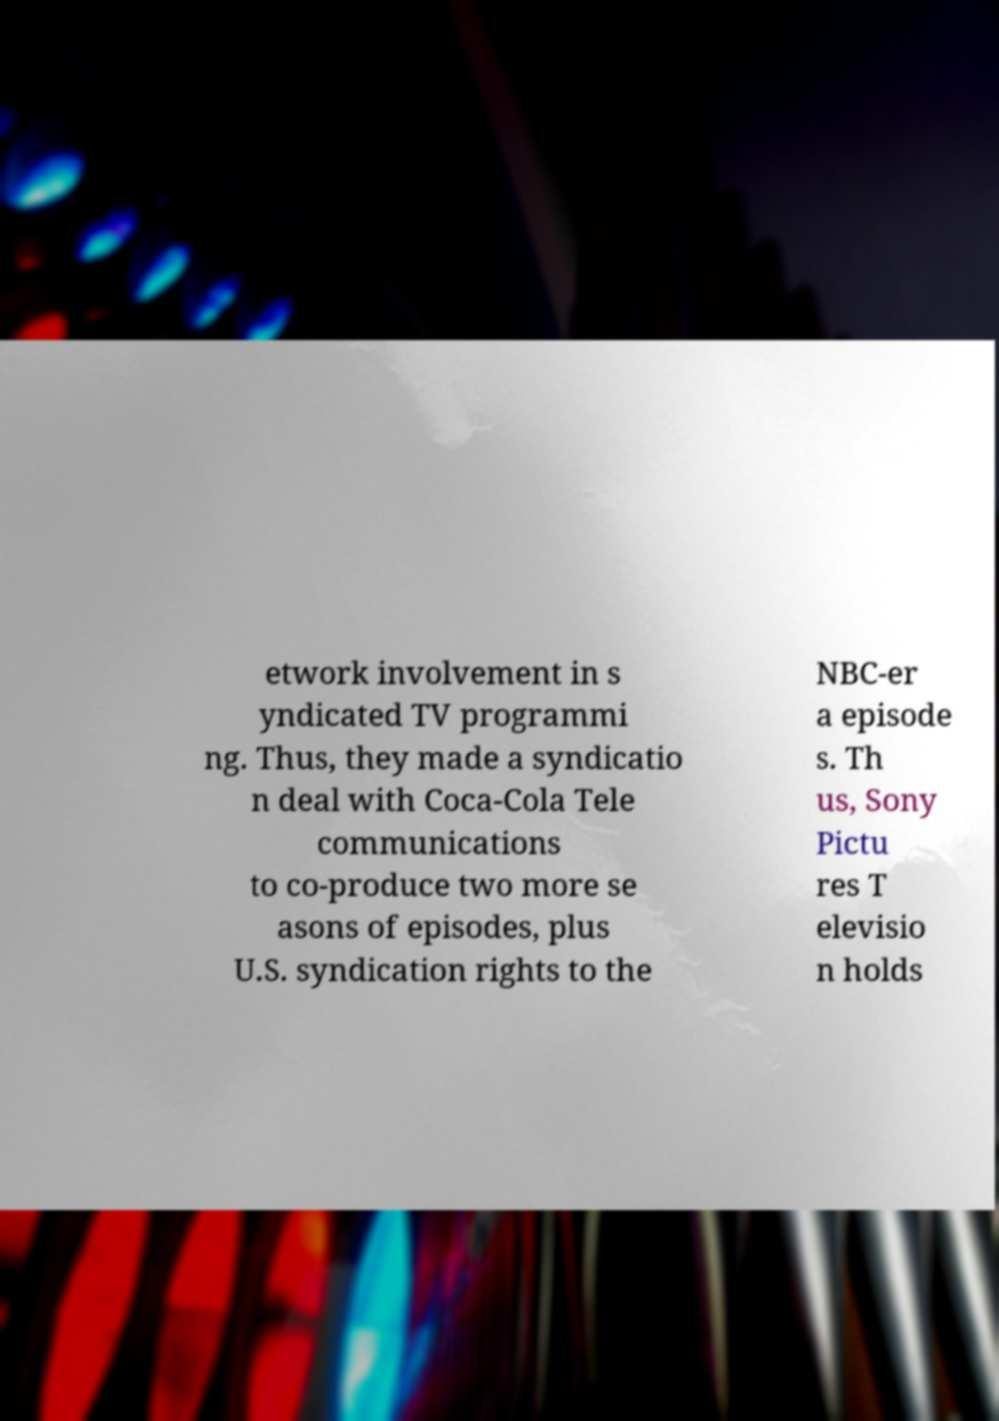Please identify and transcribe the text found in this image. etwork involvement in s yndicated TV programmi ng. Thus, they made a syndicatio n deal with Coca-Cola Tele communications to co-produce two more se asons of episodes, plus U.S. syndication rights to the NBC-er a episode s. Th us, Sony Pictu res T elevisio n holds 